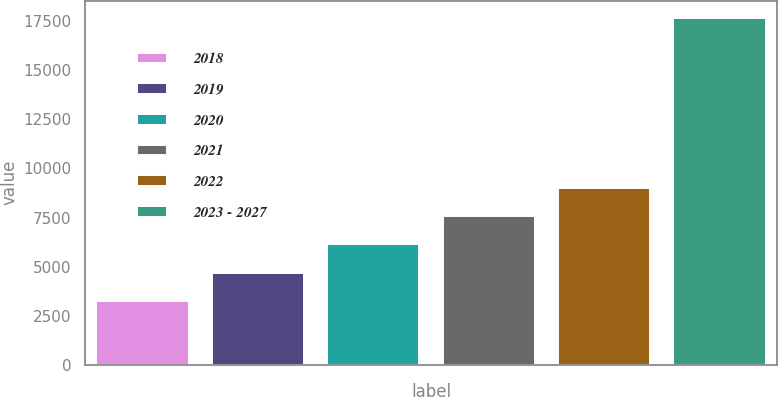Convert chart to OTSL. <chart><loc_0><loc_0><loc_500><loc_500><bar_chart><fcel>2018<fcel>2019<fcel>2020<fcel>2021<fcel>2022<fcel>2023 - 2027<nl><fcel>3246<fcel>4689.1<fcel>6132.2<fcel>7575.3<fcel>9018.4<fcel>17677<nl></chart> 